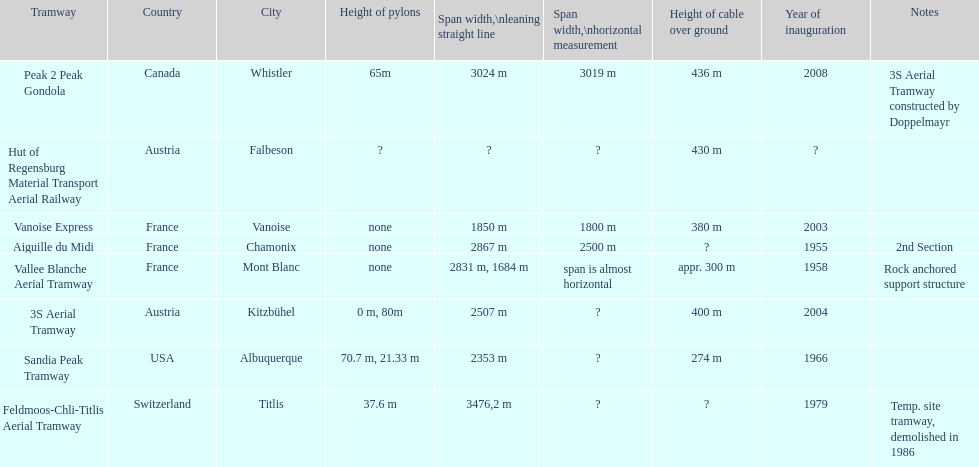Was the inauguration of the peak 2 peak gondola earlier than the vanoise express? No. 